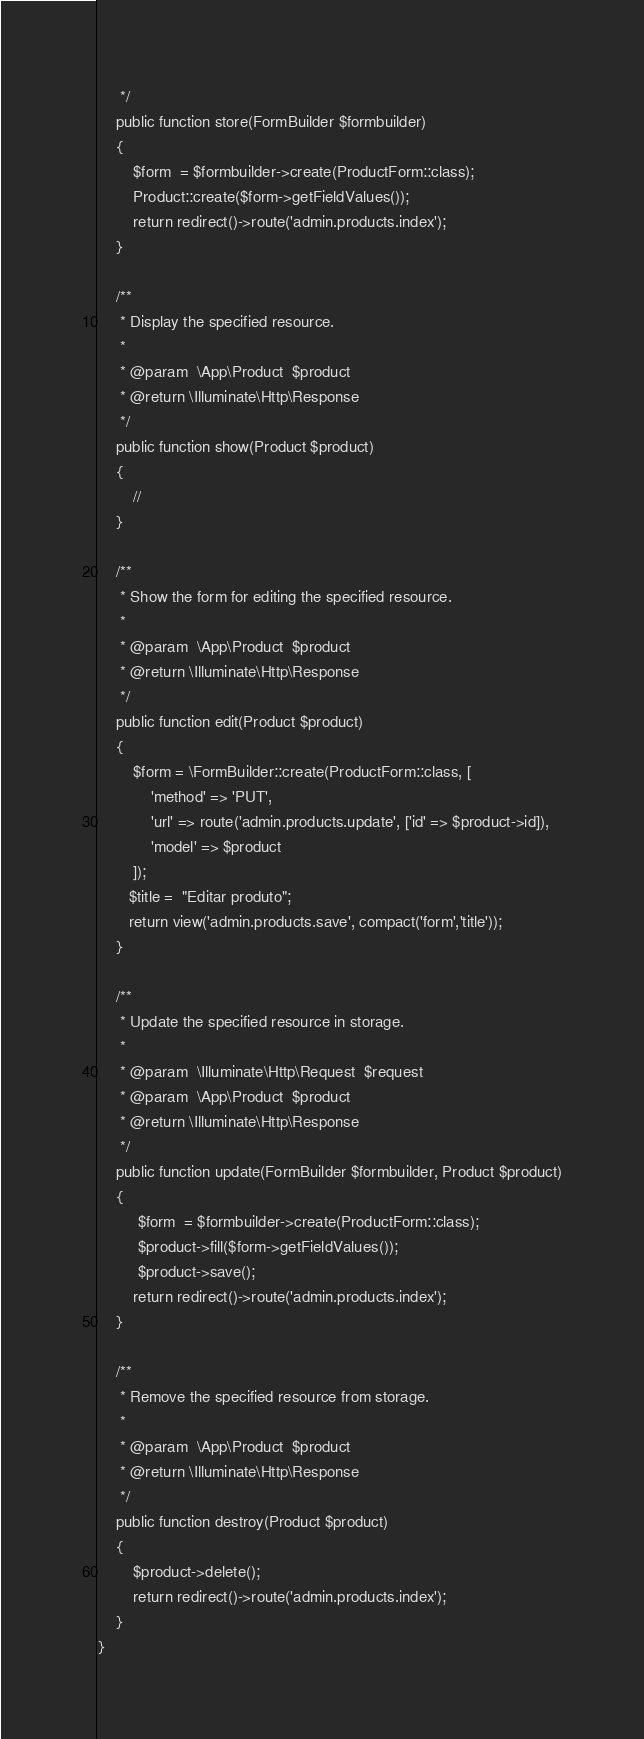Convert code to text. <code><loc_0><loc_0><loc_500><loc_500><_PHP_>     */
    public function store(FormBuilder $formbuilder)
    {
        $form  = $formbuilder->create(ProductForm::class);
        Product::create($form->getFieldValues());
        return redirect()->route('admin.products.index');
    }

    /**
     * Display the specified resource.
     *
     * @param  \App\Product  $product
     * @return \Illuminate\Http\Response
     */
    public function show(Product $product)
    {
        //
    }

    /**
     * Show the form for editing the specified resource.
     *
     * @param  \App\Product  $product
     * @return \Illuminate\Http\Response
     */
    public function edit(Product $product)
    {
        $form = \FormBuilder::create(ProductForm::class, [
            'method' => 'PUT',
            'url' => route('admin.products.update', ['id' => $product->id]),
            'model' => $product
        ]);
       $title =  "Editar produto";
       return view('admin.products.save', compact('form','title'));
    }

    /**
     * Update the specified resource in storage.
     *
     * @param  \Illuminate\Http\Request  $request
     * @param  \App\Product  $product
     * @return \Illuminate\Http\Response
     */
    public function update(FormBuilder $formbuilder, Product $product)
    {
         $form  = $formbuilder->create(ProductForm::class);
         $product->fill($form->getFieldValues());
         $product->save();
        return redirect()->route('admin.products.index');
    }

    /**
     * Remove the specified resource from storage.
     *
     * @param  \App\Product  $product
     * @return \Illuminate\Http\Response
     */
    public function destroy(Product $product)
    {
        $product->delete();
        return redirect()->route('admin.products.index');
    }
}
</code> 